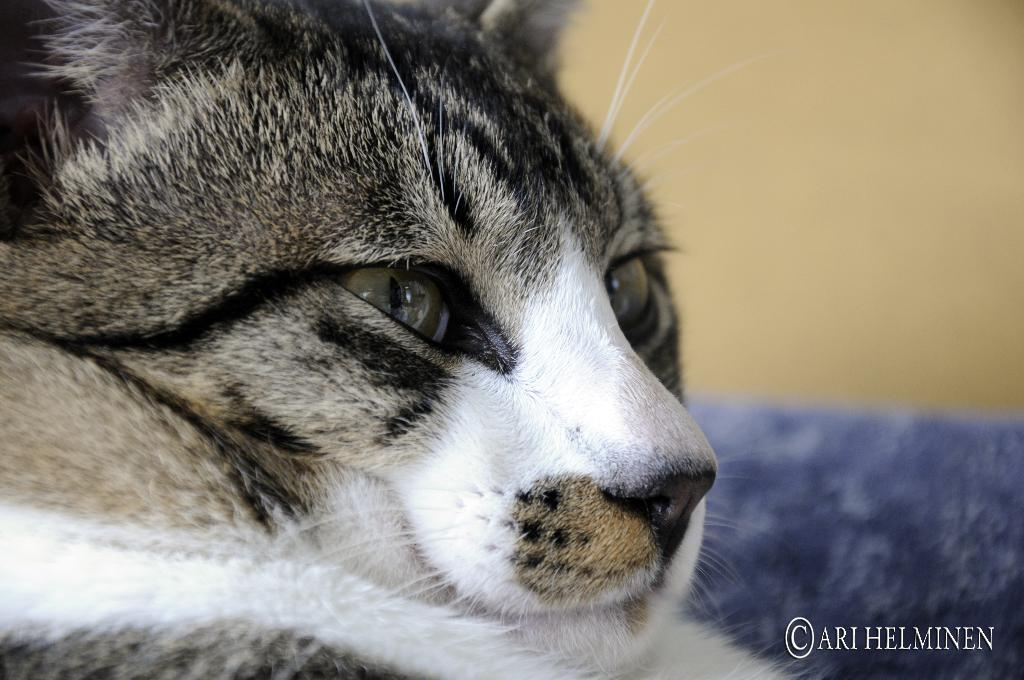What type of animal is in the image? There is a cat in the image. What color is the cat? The cat is in black and white color. What colors are present in the background of the image? The background of the image is in cream and blue color. What grade does the cat receive for its performance in the box? There is no box or performance mentioned in the image, and therefore no grade can be assigned. 